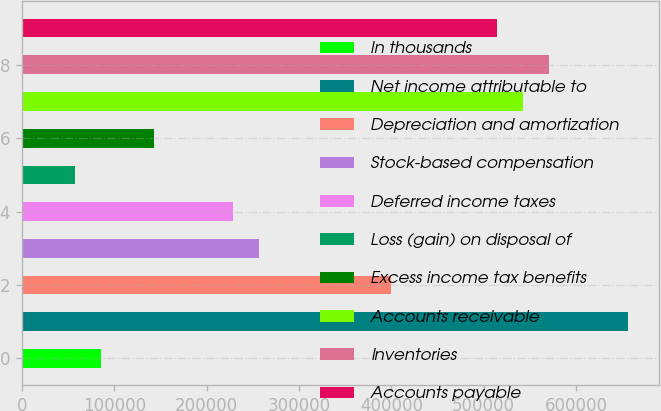<chart> <loc_0><loc_0><loc_500><loc_500><bar_chart><fcel>In thousands<fcel>Net income attributable to<fcel>Depreciation and amortization<fcel>Stock-based compensation<fcel>Deferred income taxes<fcel>Loss (gain) on disposal of<fcel>Excess income tax benefits<fcel>Accounts receivable<fcel>Inventories<fcel>Accounts payable<nl><fcel>85768.5<fcel>656758<fcel>399813<fcel>257066<fcel>228516<fcel>57219<fcel>142868<fcel>542560<fcel>571110<fcel>514011<nl></chart> 